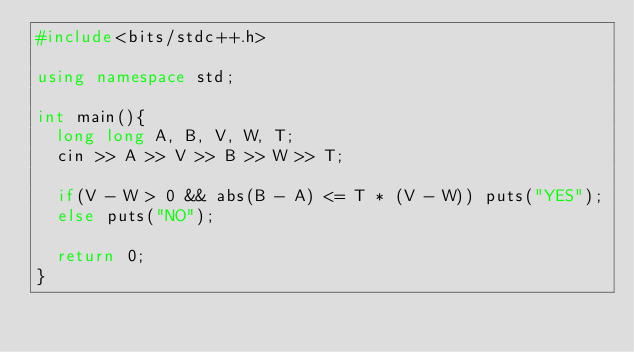Convert code to text. <code><loc_0><loc_0><loc_500><loc_500><_C++_>#include<bits/stdc++.h>

using namespace std;

int main(){
  long long A, B, V, W, T;
  cin >> A >> V >> B >> W >> T;
  
  if(V - W > 0 && abs(B - A) <= T * (V - W)) puts("YES");
  else puts("NO");
  
  return 0;
}</code> 